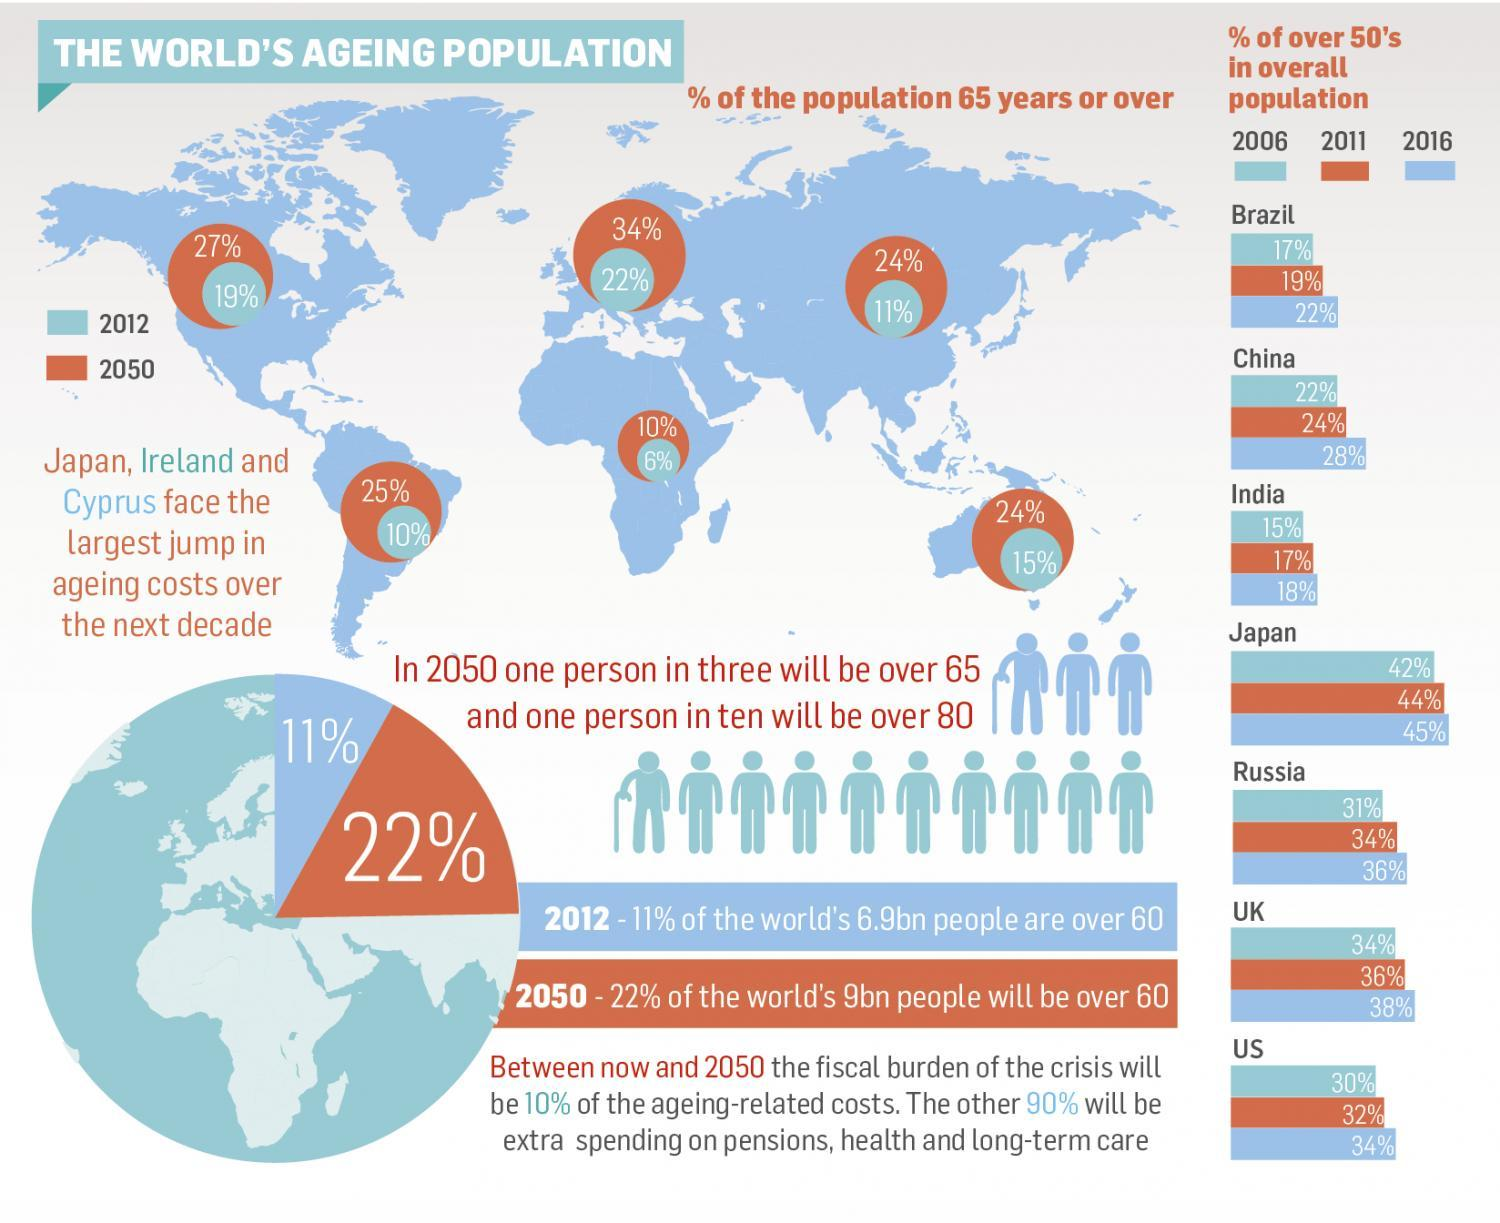What is the percentage of citizens above 50 in India in 2006?
Answer the question with a short phrase. 15% What is the percentage of citizens above 50 in UK in 2011? 36% What will be the ratio of senior citizens versus young population in 2050? 1:3 What is the percentage of citizens above 50 in China in 2016? 28% What will be the ratio of super senior citizens versus the rest of population in 2050? 1:10 Which country has the highest percentage of citizens above 50 in 2016? Japan Which continent is predicted to have the highest percentage of ageing population in 2050, US, Asia, or EU? EU 